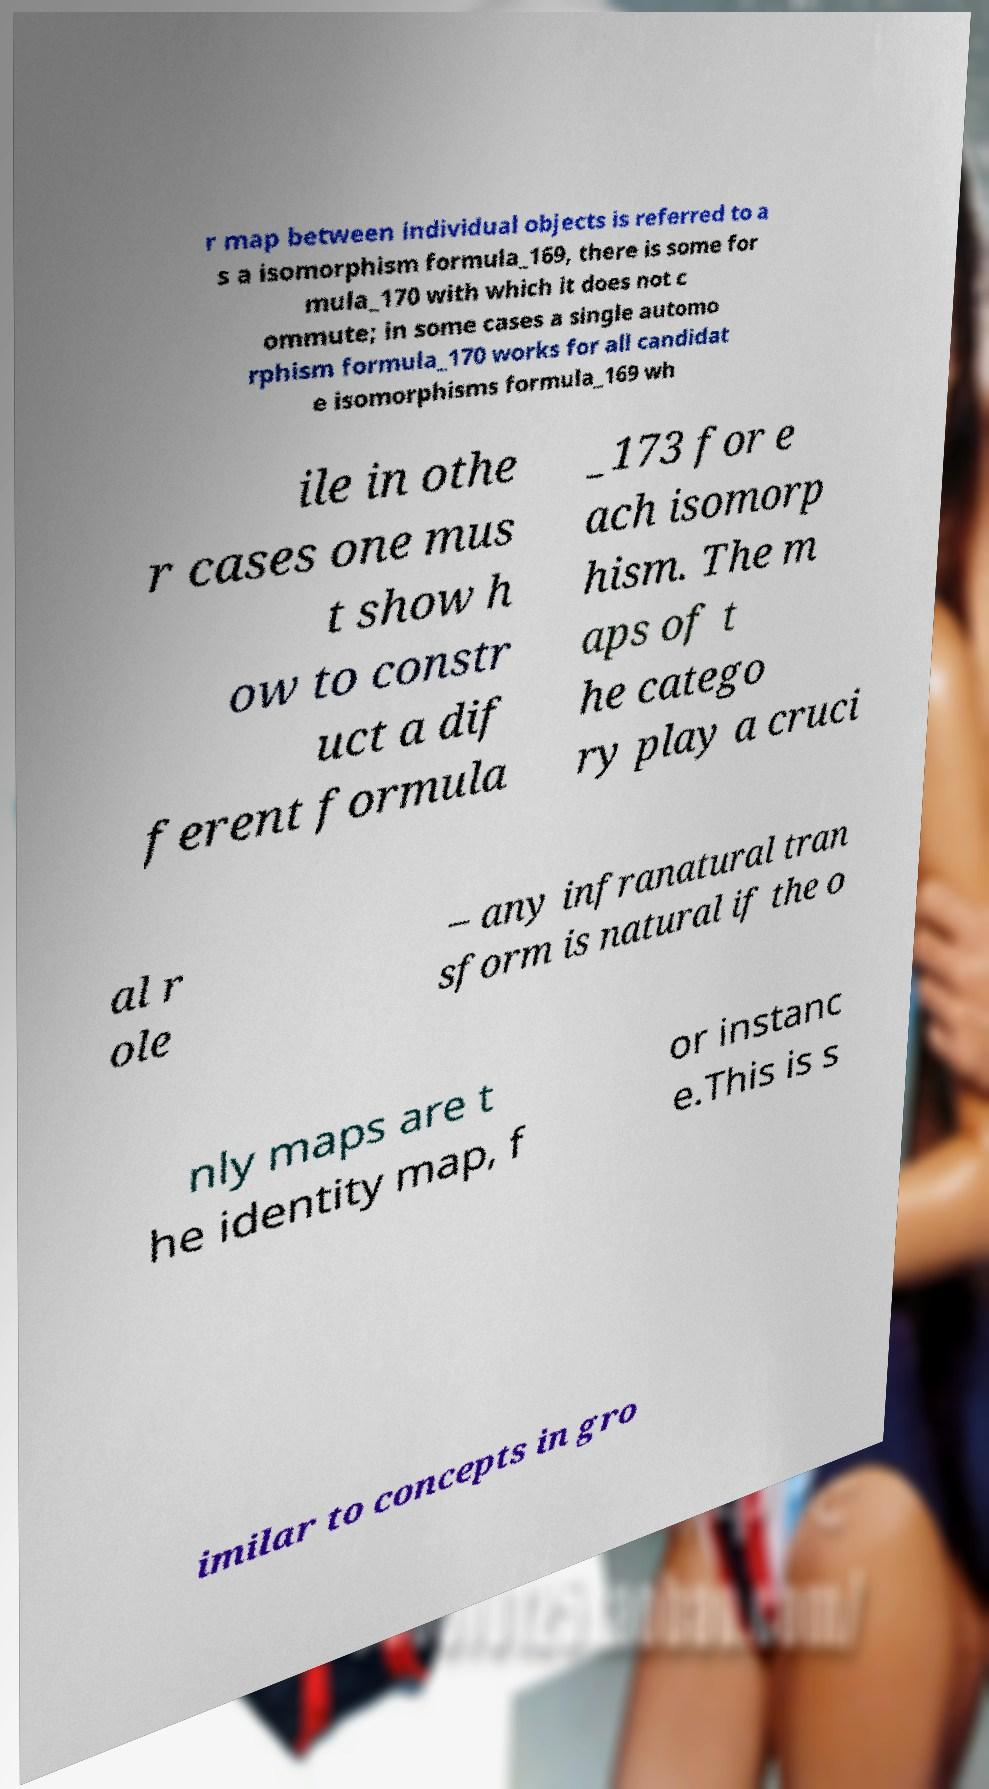Could you extract and type out the text from this image? r map between individual objects is referred to a s a isomorphism formula_169, there is some for mula_170 with which it does not c ommute; in some cases a single automo rphism formula_170 works for all candidat e isomorphisms formula_169 wh ile in othe r cases one mus t show h ow to constr uct a dif ferent formula _173 for e ach isomorp hism. The m aps of t he catego ry play a cruci al r ole – any infranatural tran sform is natural if the o nly maps are t he identity map, f or instanc e.This is s imilar to concepts in gro 